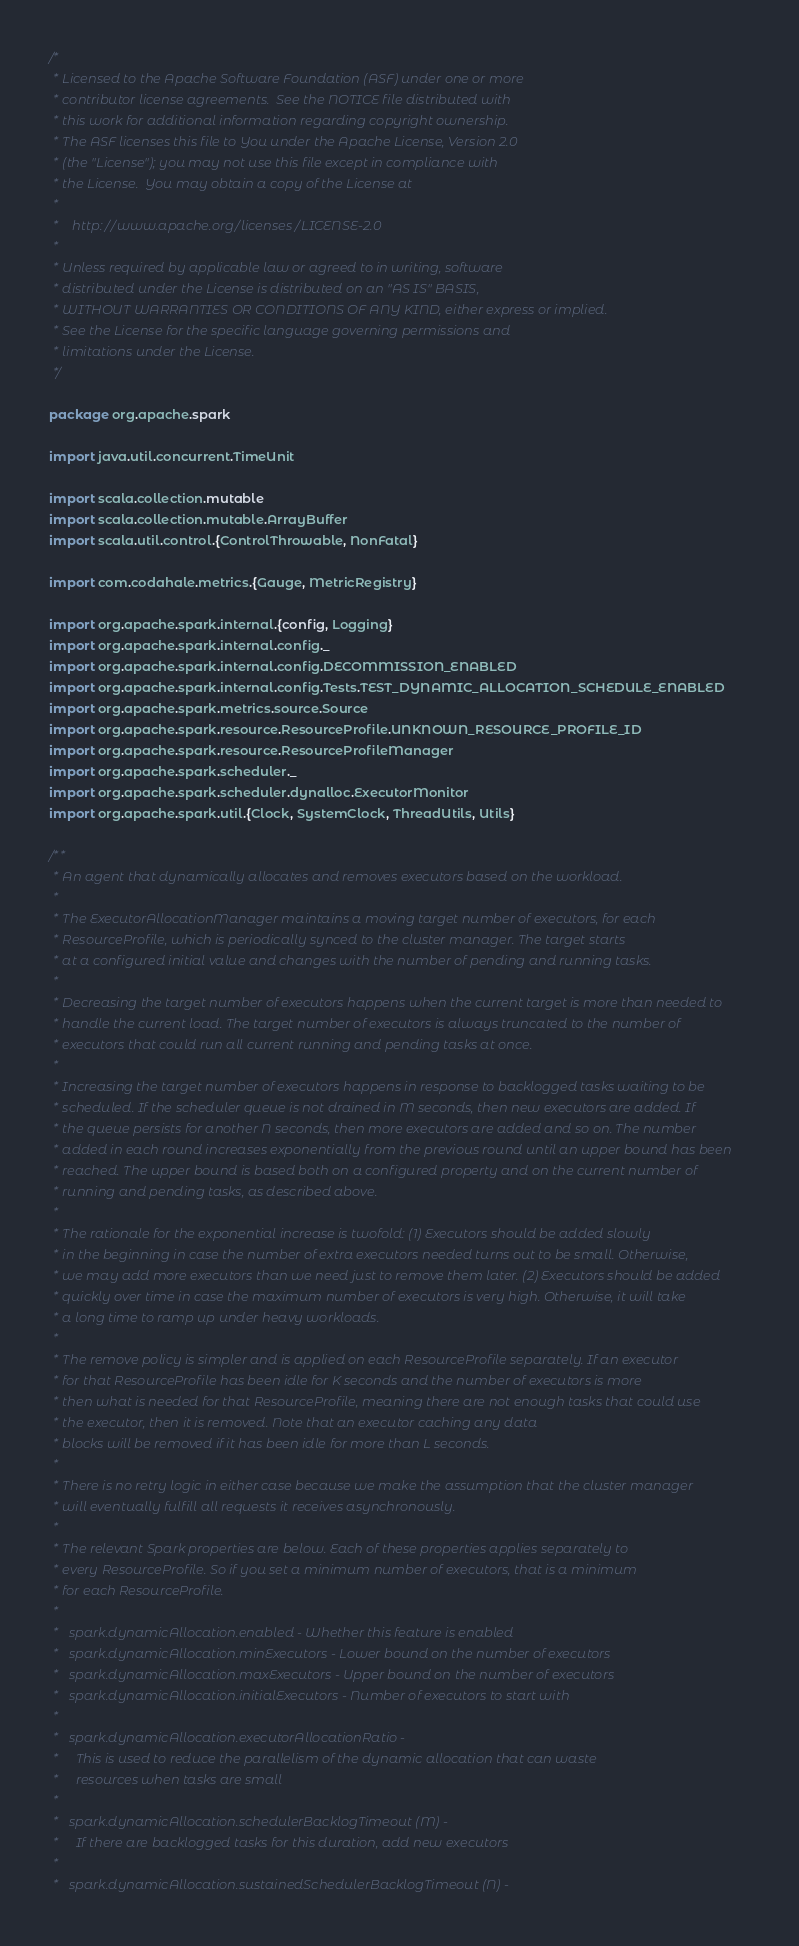<code> <loc_0><loc_0><loc_500><loc_500><_Scala_>/*
 * Licensed to the Apache Software Foundation (ASF) under one or more
 * contributor license agreements.  See the NOTICE file distributed with
 * this work for additional information regarding copyright ownership.
 * The ASF licenses this file to You under the Apache License, Version 2.0
 * (the "License"); you may not use this file except in compliance with
 * the License.  You may obtain a copy of the License at
 *
 *    http://www.apache.org/licenses/LICENSE-2.0
 *
 * Unless required by applicable law or agreed to in writing, software
 * distributed under the License is distributed on an "AS IS" BASIS,
 * WITHOUT WARRANTIES OR CONDITIONS OF ANY KIND, either express or implied.
 * See the License for the specific language governing permissions and
 * limitations under the License.
 */

package org.apache.spark

import java.util.concurrent.TimeUnit

import scala.collection.mutable
import scala.collection.mutable.ArrayBuffer
import scala.util.control.{ControlThrowable, NonFatal}

import com.codahale.metrics.{Gauge, MetricRegistry}

import org.apache.spark.internal.{config, Logging}
import org.apache.spark.internal.config._
import org.apache.spark.internal.config.DECOMMISSION_ENABLED
import org.apache.spark.internal.config.Tests.TEST_DYNAMIC_ALLOCATION_SCHEDULE_ENABLED
import org.apache.spark.metrics.source.Source
import org.apache.spark.resource.ResourceProfile.UNKNOWN_RESOURCE_PROFILE_ID
import org.apache.spark.resource.ResourceProfileManager
import org.apache.spark.scheduler._
import org.apache.spark.scheduler.dynalloc.ExecutorMonitor
import org.apache.spark.util.{Clock, SystemClock, ThreadUtils, Utils}

/**
 * An agent that dynamically allocates and removes executors based on the workload.
 *
 * The ExecutorAllocationManager maintains a moving target number of executors, for each
 * ResourceProfile, which is periodically synced to the cluster manager. The target starts
 * at a configured initial value and changes with the number of pending and running tasks.
 *
 * Decreasing the target number of executors happens when the current target is more than needed to
 * handle the current load. The target number of executors is always truncated to the number of
 * executors that could run all current running and pending tasks at once.
 *
 * Increasing the target number of executors happens in response to backlogged tasks waiting to be
 * scheduled. If the scheduler queue is not drained in M seconds, then new executors are added. If
 * the queue persists for another N seconds, then more executors are added and so on. The number
 * added in each round increases exponentially from the previous round until an upper bound has been
 * reached. The upper bound is based both on a configured property and on the current number of
 * running and pending tasks, as described above.
 *
 * The rationale for the exponential increase is twofold: (1) Executors should be added slowly
 * in the beginning in case the number of extra executors needed turns out to be small. Otherwise,
 * we may add more executors than we need just to remove them later. (2) Executors should be added
 * quickly over time in case the maximum number of executors is very high. Otherwise, it will take
 * a long time to ramp up under heavy workloads.
 *
 * The remove policy is simpler and is applied on each ResourceProfile separately. If an executor
 * for that ResourceProfile has been idle for K seconds and the number of executors is more
 * then what is needed for that ResourceProfile, meaning there are not enough tasks that could use
 * the executor, then it is removed. Note that an executor caching any data
 * blocks will be removed if it has been idle for more than L seconds.
 *
 * There is no retry logic in either case because we make the assumption that the cluster manager
 * will eventually fulfill all requests it receives asynchronously.
 *
 * The relevant Spark properties are below. Each of these properties applies separately to
 * every ResourceProfile. So if you set a minimum number of executors, that is a minimum
 * for each ResourceProfile.
 *
 *   spark.dynamicAllocation.enabled - Whether this feature is enabled
 *   spark.dynamicAllocation.minExecutors - Lower bound on the number of executors
 *   spark.dynamicAllocation.maxExecutors - Upper bound on the number of executors
 *   spark.dynamicAllocation.initialExecutors - Number of executors to start with
 *
 *   spark.dynamicAllocation.executorAllocationRatio -
 *     This is used to reduce the parallelism of the dynamic allocation that can waste
 *     resources when tasks are small
 *
 *   spark.dynamicAllocation.schedulerBacklogTimeout (M) -
 *     If there are backlogged tasks for this duration, add new executors
 *
 *   spark.dynamicAllocation.sustainedSchedulerBacklogTimeout (N) -</code> 